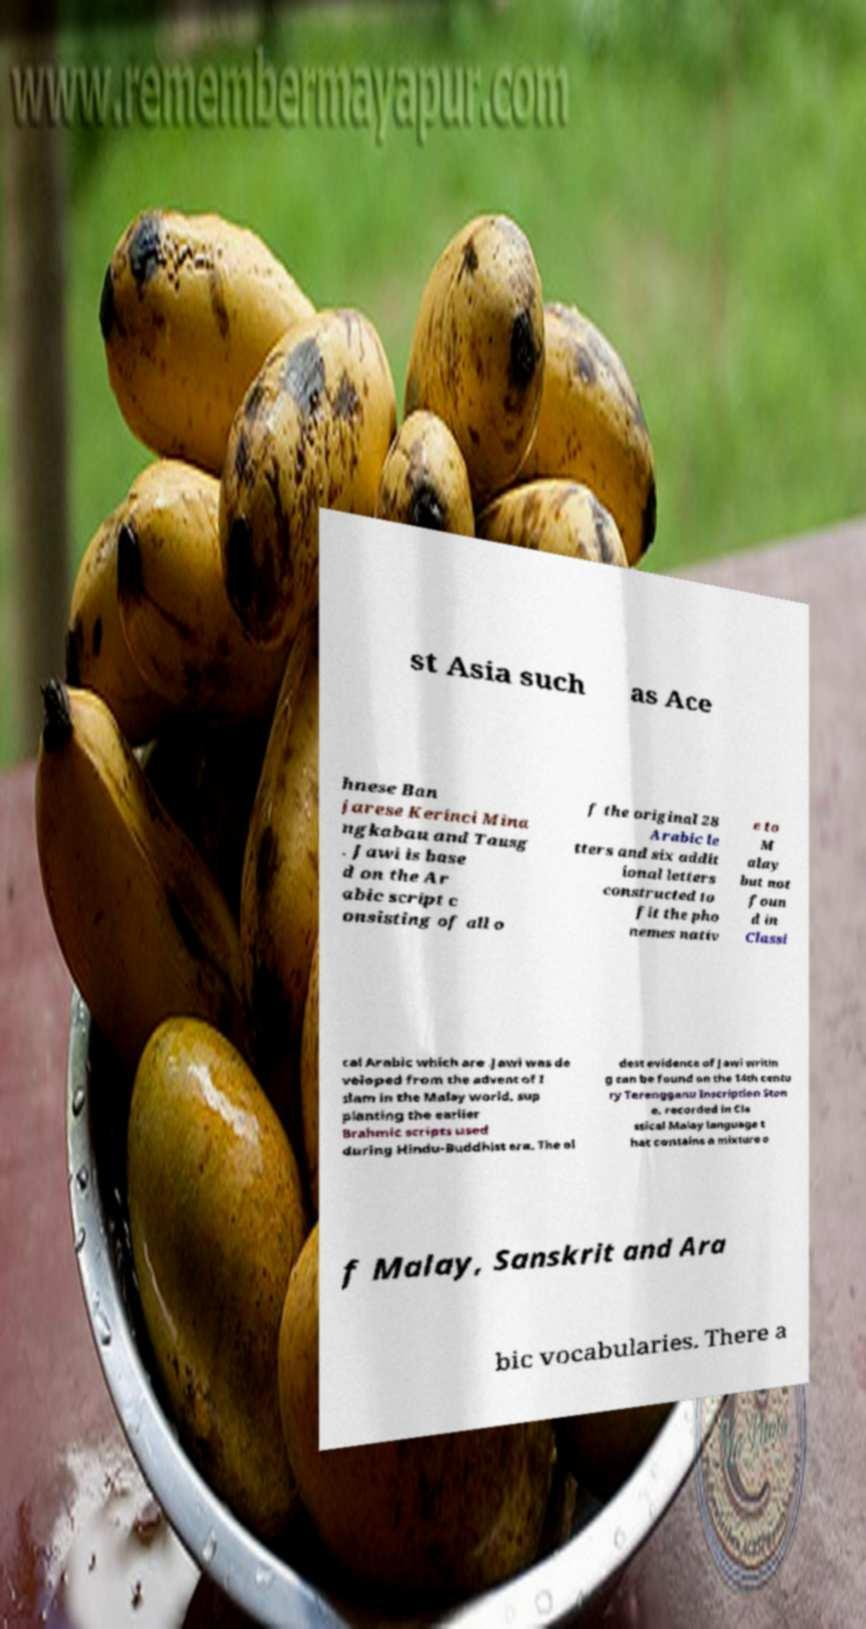Could you extract and type out the text from this image? st Asia such as Ace hnese Ban jarese Kerinci Mina ngkabau and Tausg . Jawi is base d on the Ar abic script c onsisting of all o f the original 28 Arabic le tters and six addit ional letters constructed to fit the pho nemes nativ e to M alay but not foun d in Classi cal Arabic which are .Jawi was de veloped from the advent of I slam in the Malay world, sup planting the earlier Brahmic scripts used during Hindu-Buddhist era. The ol dest evidence of Jawi writin g can be found on the 14th centu ry Terengganu Inscription Ston e, recorded in Cla ssical Malay language t hat contains a mixture o f Malay, Sanskrit and Ara bic vocabularies. There a 